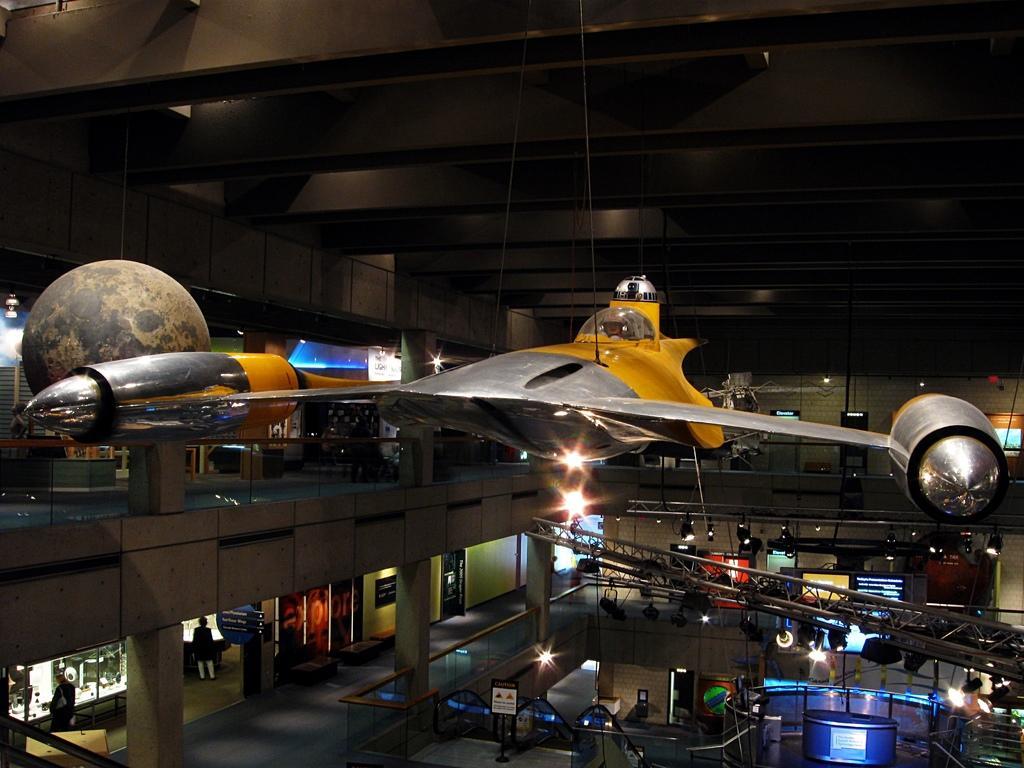Describe this image in one or two sentences. In this image there is a spaceship hanging to the ceiling. At the bottom there are chairs and stands. In the middle there are lights. On the left side there are pillars. It looks like a hall in which there are few people working with the computers. 